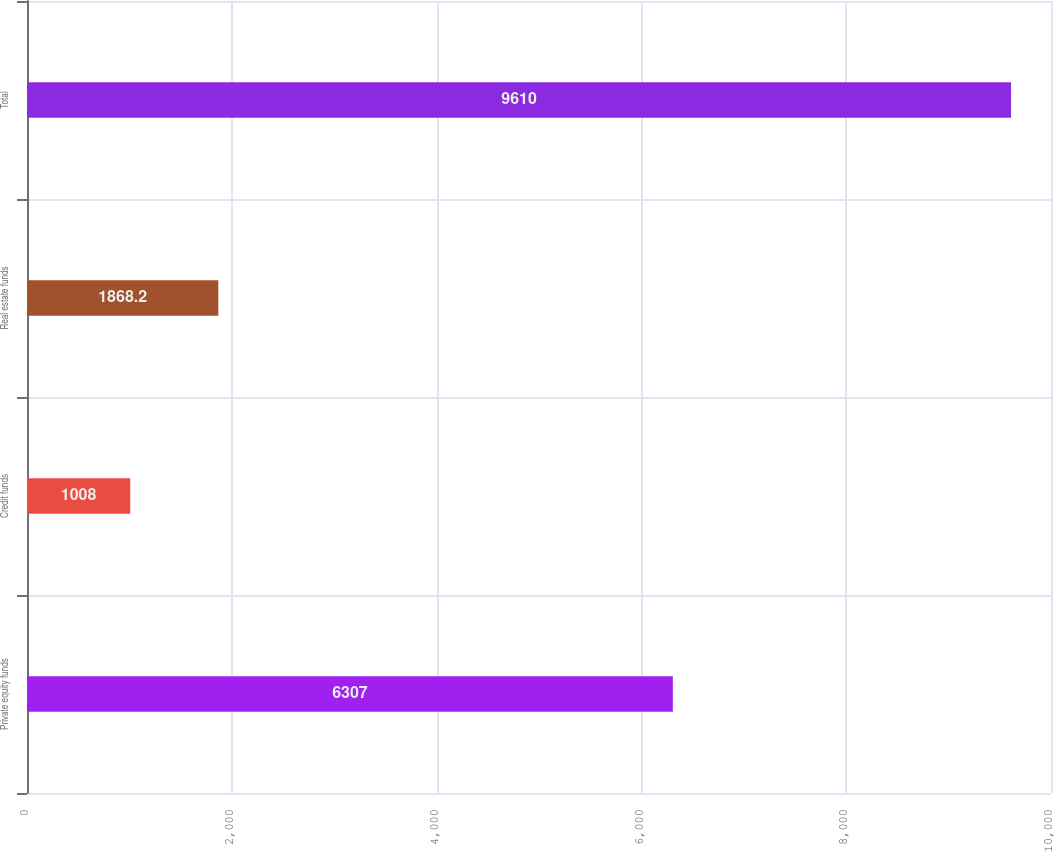Convert chart. <chart><loc_0><loc_0><loc_500><loc_500><bar_chart><fcel>Private equity funds<fcel>Credit funds<fcel>Real estate funds<fcel>Total<nl><fcel>6307<fcel>1008<fcel>1868.2<fcel>9610<nl></chart> 